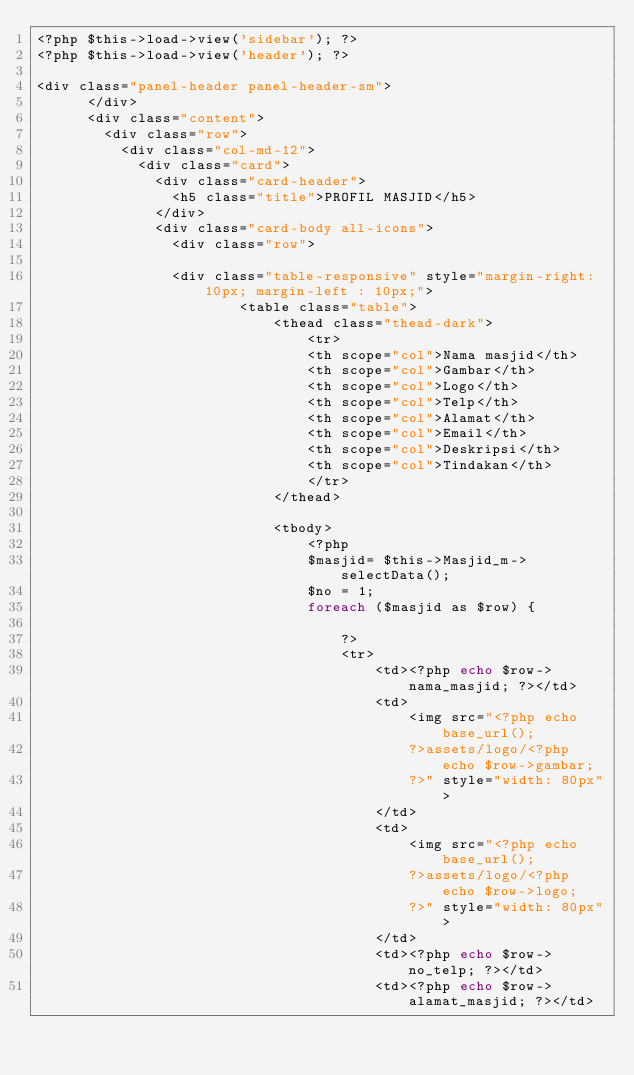<code> <loc_0><loc_0><loc_500><loc_500><_PHP_><?php $this->load->view('sidebar'); ?>
<?php $this->load->view('header'); ?>

<div class="panel-header panel-header-sm">
      </div>
      <div class="content">
        <div class="row">
          <div class="col-md-12">
            <div class="card">
              <div class="card-header">
                <h5 class="title">PROFIL MASJID</h5>
              </div>
              <div class="card-body all-icons">
                <div class="row">

                <div class="table-responsive" style="margin-right: 10px; margin-left : 10px;"> 
                        <table class="table">
                            <thead class="thead-dark">
                                <tr>
                                <th scope="col">Nama masjid</th>
                                <th scope="col">Gambar</th>
                                <th scope="col">Logo</th>
                                <th scope="col">Telp</th>
                                <th scope="col">Alamat</th>
                                <th scope="col">Email</th>
                                <th scope="col">Deskripsi</th>
                                <th scope="col">Tindakan</th>
                                </tr>
                            </thead>

                            <tbody>
                                <?php
                                $masjid= $this->Masjid_m->selectData();
                                $no = 1;
                                foreach ($masjid as $row) {
                                  
                                    ?>    
                                    <tr>
                                        <td><?php echo $row->nama_masjid; ?></td>
                                        <td>
                                            <img src="<?php echo base_url();
                                            ?>assets/logo/<?php echo $row->gambar;
                                            ?>" style="width: 80px"> 
                                        </td>
                                        <td>
                                            <img src="<?php echo base_url();
                                            ?>assets/logo/<?php echo $row->logo;
                                            ?>" style="width: 80px"> 
                                        </td>
                                        <td><?php echo $row->no_telp; ?></td>
                                        <td><?php echo $row->alamat_masjid; ?></td></code> 